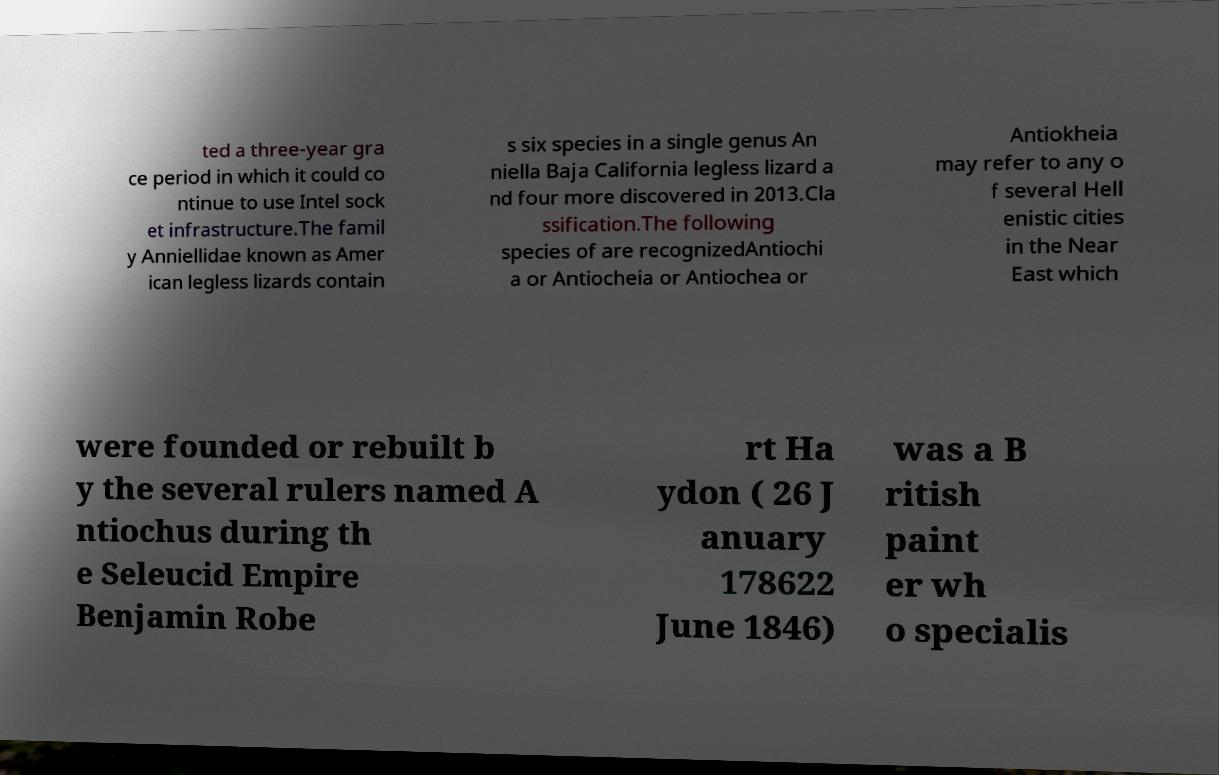What messages or text are displayed in this image? I need them in a readable, typed format. ted a three-year gra ce period in which it could co ntinue to use Intel sock et infrastructure.The famil y Anniellidae known as Amer ican legless lizards contain s six species in a single genus An niella Baja California legless lizard a nd four more discovered in 2013.Cla ssification.The following species of are recognizedAntiochi a or Antiocheia or Antiochea or Antiokheia may refer to any o f several Hell enistic cities in the Near East which were founded or rebuilt b y the several rulers named A ntiochus during th e Seleucid Empire Benjamin Robe rt Ha ydon ( 26 J anuary 178622 June 1846) was a B ritish paint er wh o specialis 